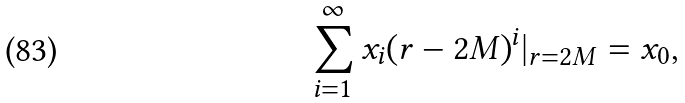<formula> <loc_0><loc_0><loc_500><loc_500>\sum _ { i = 1 } ^ { \infty } x _ { i } ( r - 2 M ) ^ { i } | _ { r = 2 M } = x _ { 0 } ,</formula> 